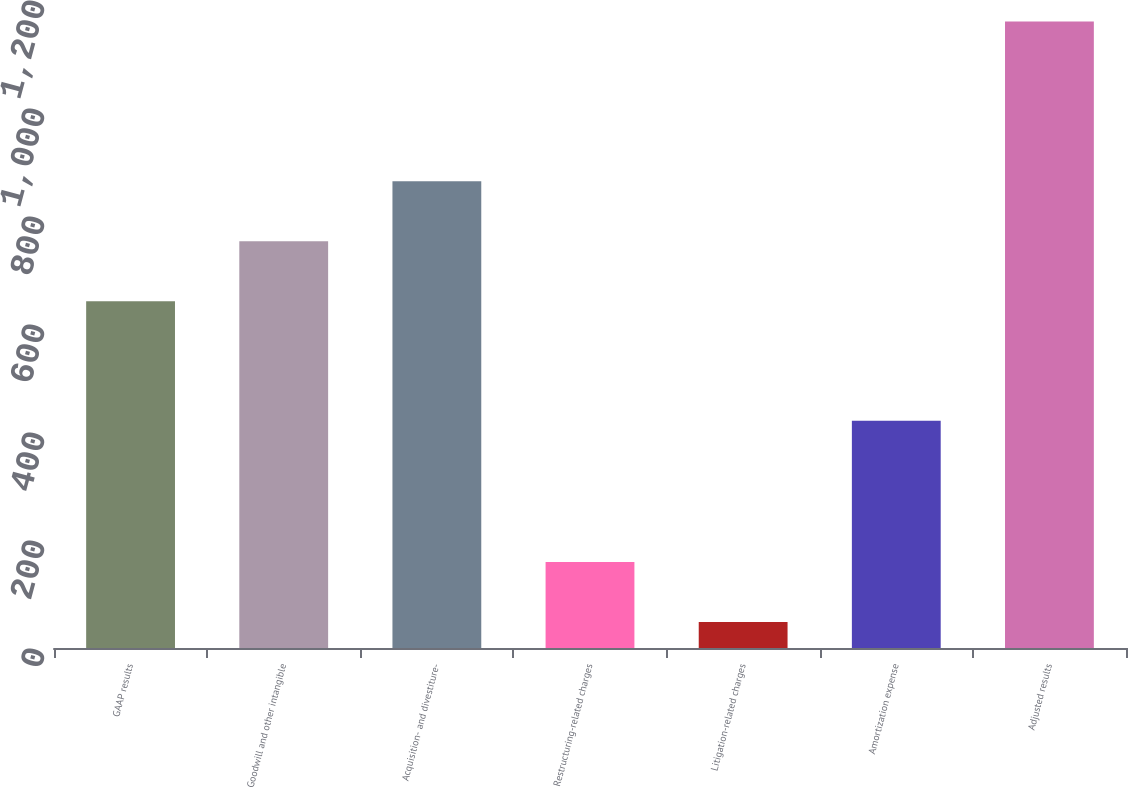Convert chart to OTSL. <chart><loc_0><loc_0><loc_500><loc_500><bar_chart><fcel>GAAP results<fcel>Goodwill and other intangible<fcel>Acquisition- and divestiture-<fcel>Restructuring-related charges<fcel>Litigation-related charges<fcel>Amortization expense<fcel>Adjusted results<nl><fcel>642<fcel>753.2<fcel>864.4<fcel>159.2<fcel>48<fcel>421<fcel>1160<nl></chart> 